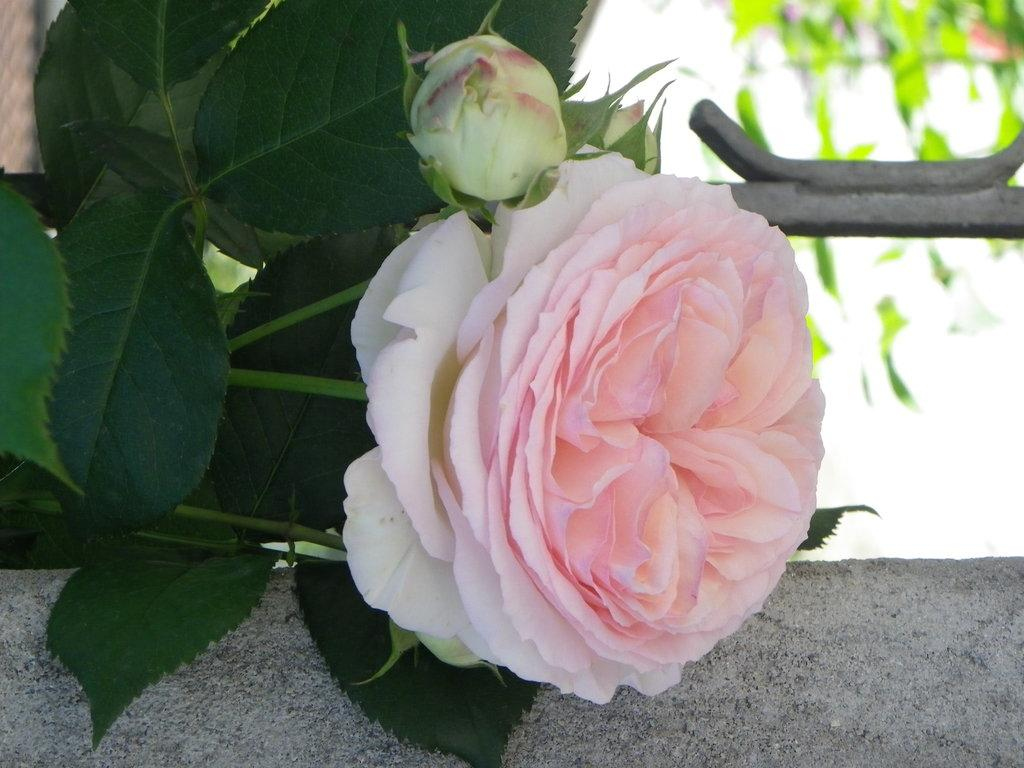What is the main subject of the image? There is a flower in the center of the image. Can you describe the flower in more detail? Unfortunately, the image does not provide enough detail to describe the flower further. Is there anything else in the image besides the flower? The facts provided do not mention any other objects or subjects in the image. What type of rhythm can be heard coming from the flower in the image? There is no sound or rhythm associated with the flower in the image. 